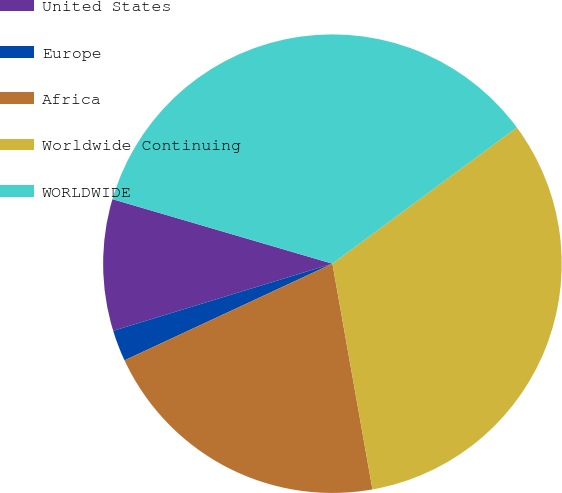<chart> <loc_0><loc_0><loc_500><loc_500><pie_chart><fcel>United States<fcel>Europe<fcel>Africa<fcel>Worldwide Continuing<fcel>WORLDWIDE<nl><fcel>9.27%<fcel>2.2%<fcel>20.87%<fcel>32.33%<fcel>35.34%<nl></chart> 